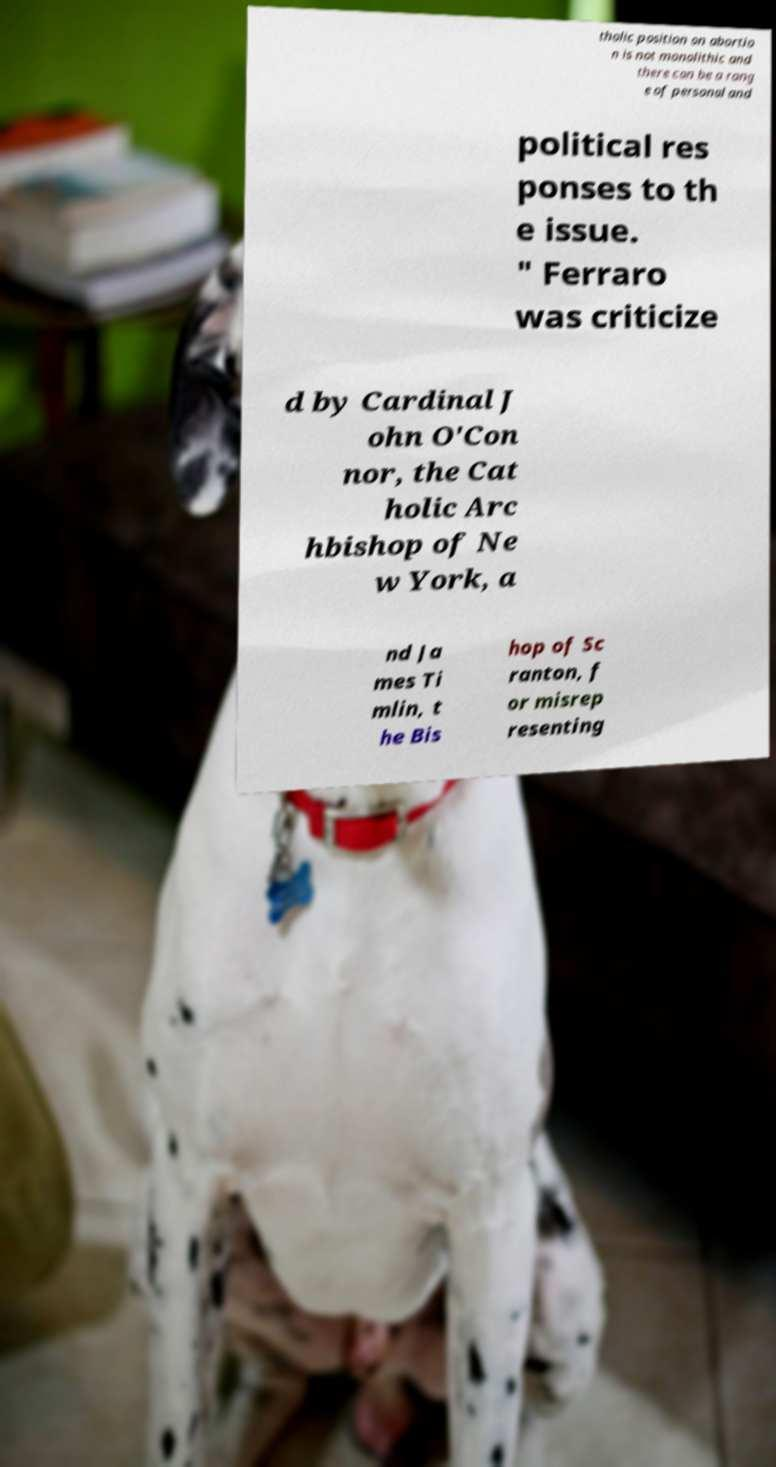Could you assist in decoding the text presented in this image and type it out clearly? tholic position on abortio n is not monolithic and there can be a rang e of personal and political res ponses to th e issue. " Ferraro was criticize d by Cardinal J ohn O'Con nor, the Cat holic Arc hbishop of Ne w York, a nd Ja mes Ti mlin, t he Bis hop of Sc ranton, f or misrep resenting 